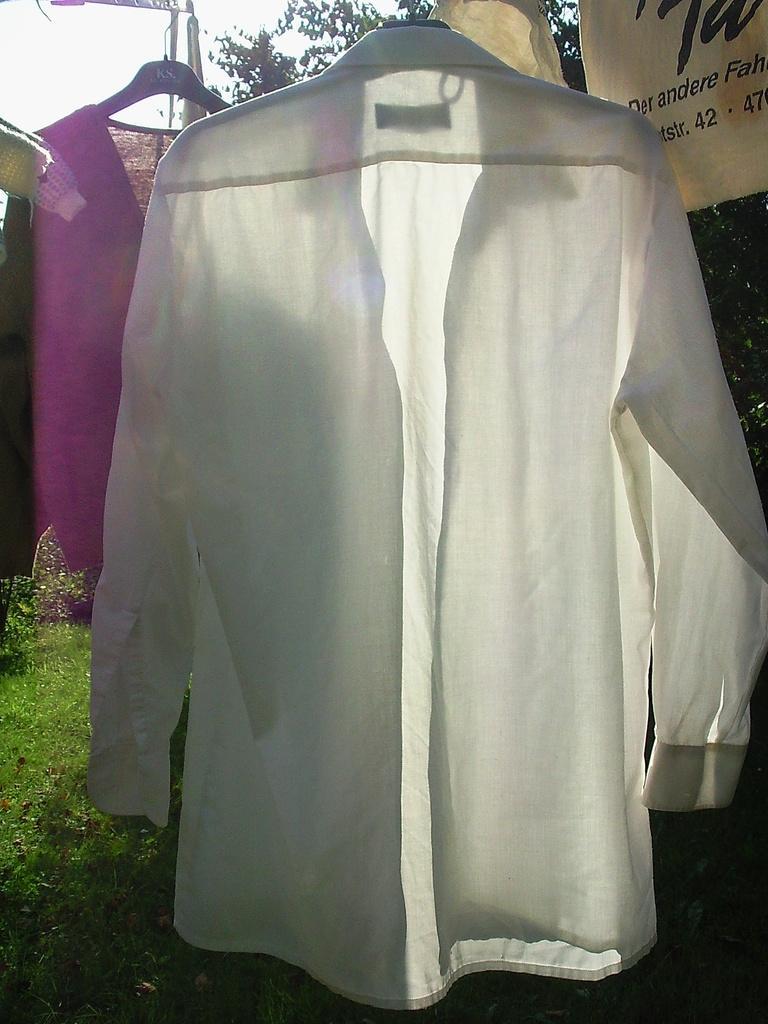Describe this image in one or two sentences. In this picture in the center there are clothes hanging and there is grass on the ground in the background there are trees on the right side there is a cloth with some text written on it 